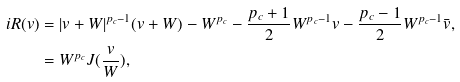Convert formula to latex. <formula><loc_0><loc_0><loc_500><loc_500>i R ( v ) & = | v + W | ^ { p _ { c } - 1 } ( v + W ) - W ^ { p _ { c } } - \frac { p _ { c } + 1 } 2 W ^ { p _ { c } - 1 } v - \frac { p _ { c } - 1 } 2 W ^ { p _ { c } - 1 } \bar { v } , \\ & = W ^ { p _ { c } } J ( \frac { v } { W } ) ,</formula> 